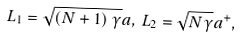<formula> <loc_0><loc_0><loc_500><loc_500>L _ { 1 } = \sqrt { \left ( N + 1 \right ) \gamma } a , \, L _ { 2 } = \sqrt { N \gamma } a ^ { + } ,</formula> 